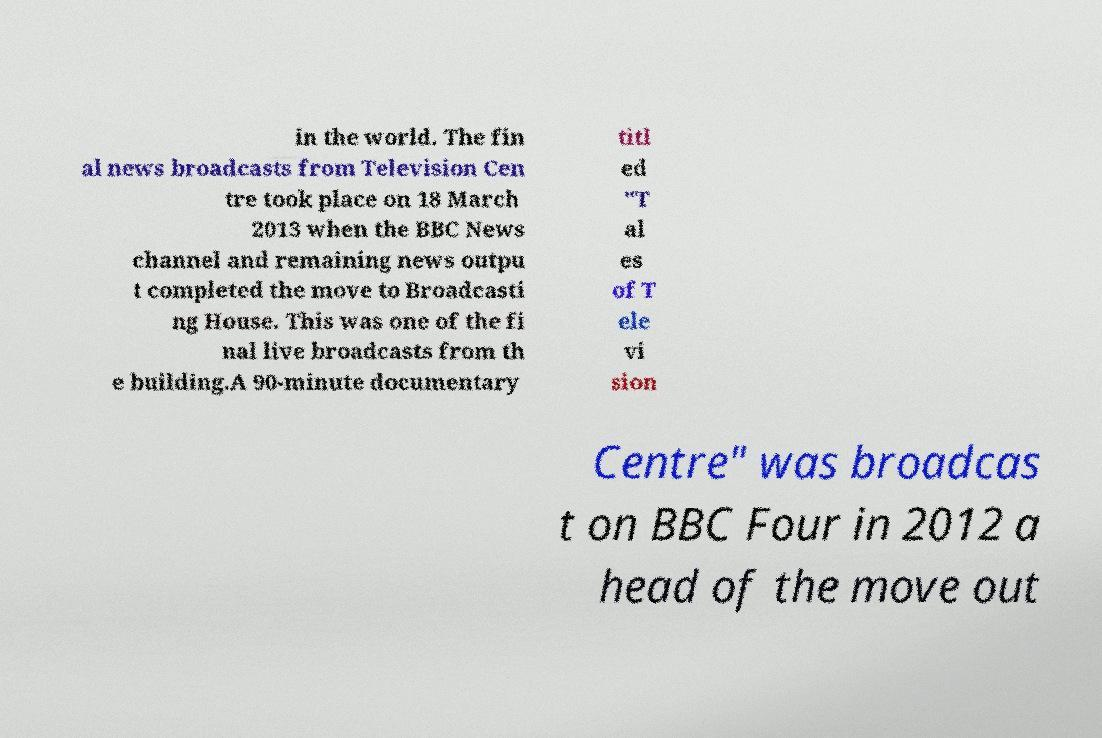I need the written content from this picture converted into text. Can you do that? in the world. The fin al news broadcasts from Television Cen tre took place on 18 March 2013 when the BBC News channel and remaining news outpu t completed the move to Broadcasti ng House. This was one of the fi nal live broadcasts from th e building.A 90-minute documentary titl ed "T al es of T ele vi sion Centre" was broadcas t on BBC Four in 2012 a head of the move out 